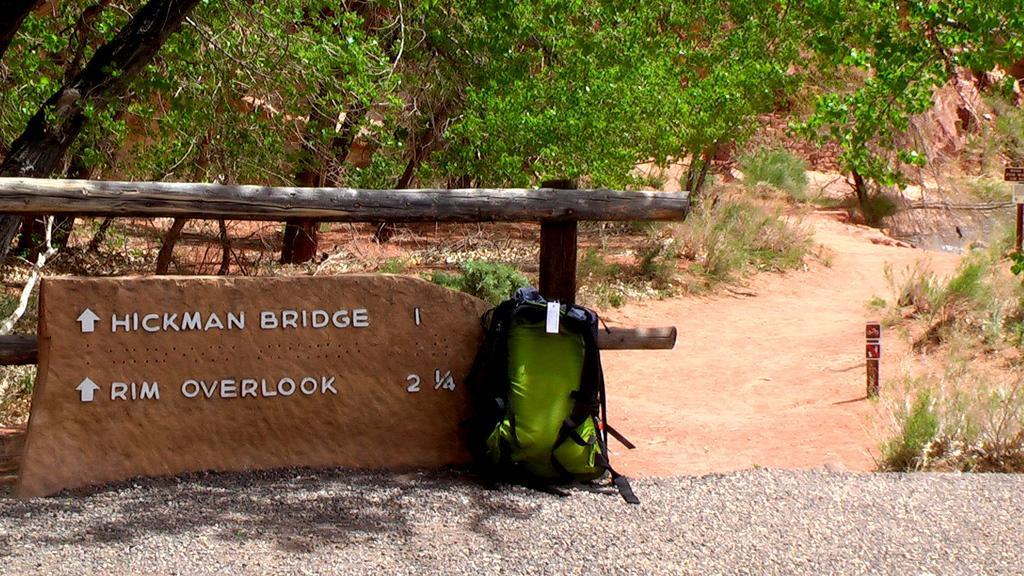Please provide a concise description of this image. In the image we can see there is a travel backpack and on the brick stone there is written "Hickman Bridge" and at the back there are lot of trees. 